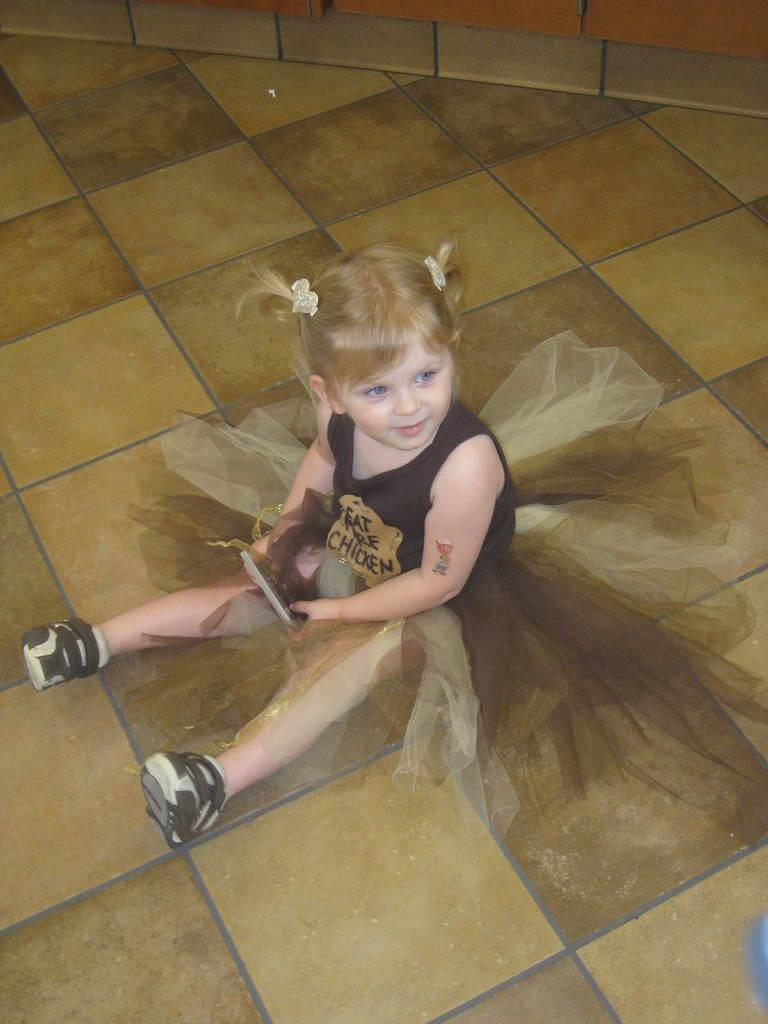Who is the main subject in the image? There is a girl in the image. What is the girl doing in the image? The girl is sitting on the floor. What is the girl holding in the image? The girl is holding an object with her hands. What type of engine can be seen in the image? There is no engine present in the image; it features a girl sitting on the floor and holding an object. How many forks are visible in the image? There are no forks visible in the image. 